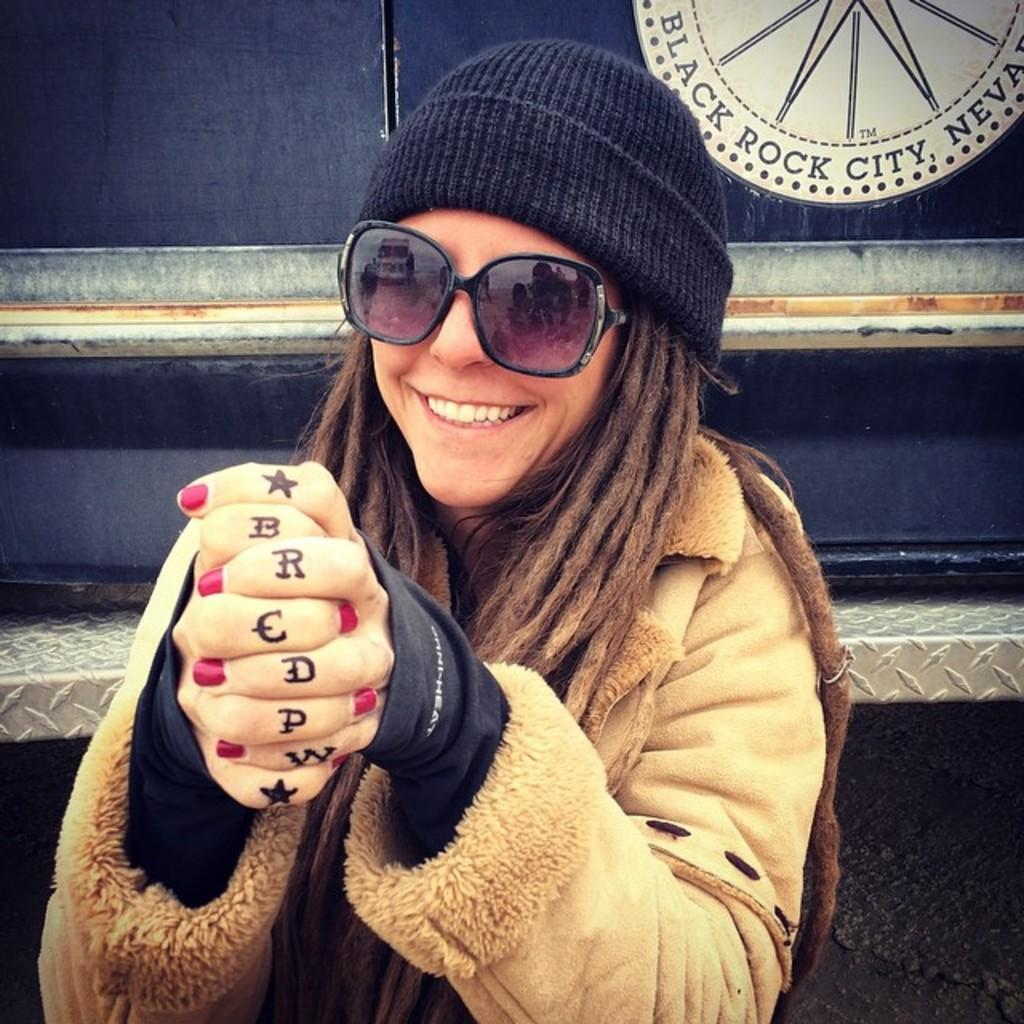Who is present in the image? There is a woman in the image. What can be seen in the background of the image? There is a wall in the background of the image. How does the woman express her anger in the image? There is no indication of anger in the image, as the woman's expression or body language is not described. 